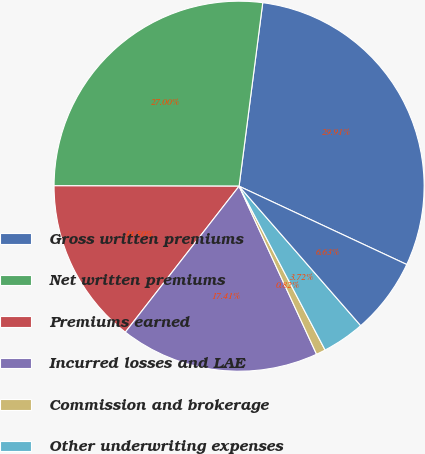Convert chart to OTSL. <chart><loc_0><loc_0><loc_500><loc_500><pie_chart><fcel>Gross written premiums<fcel>Net written premiums<fcel>Premiums earned<fcel>Incurred losses and LAE<fcel>Commission and brokerage<fcel>Other underwriting expenses<fcel>Underwriting gain (loss)<nl><fcel>29.91%<fcel>27.0%<fcel>14.5%<fcel>17.41%<fcel>0.82%<fcel>3.72%<fcel>6.63%<nl></chart> 